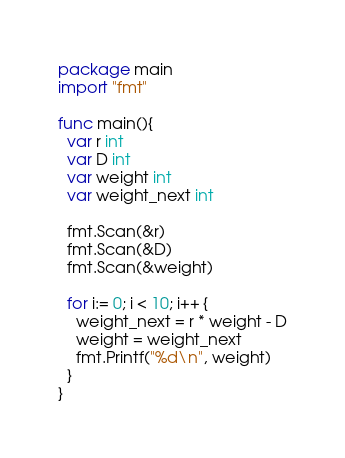Convert code to text. <code><loc_0><loc_0><loc_500><loc_500><_Go_>package main
import "fmt"

func main(){
  var r int
  var D int
  var weight int
  var weight_next int

  fmt.Scan(&r)
  fmt.Scan(&D)
  fmt.Scan(&weight)

  for i:= 0; i < 10; i++ {
    weight_next = r * weight - D
    weight = weight_next
    fmt.Printf("%d\n", weight)
  }
}</code> 